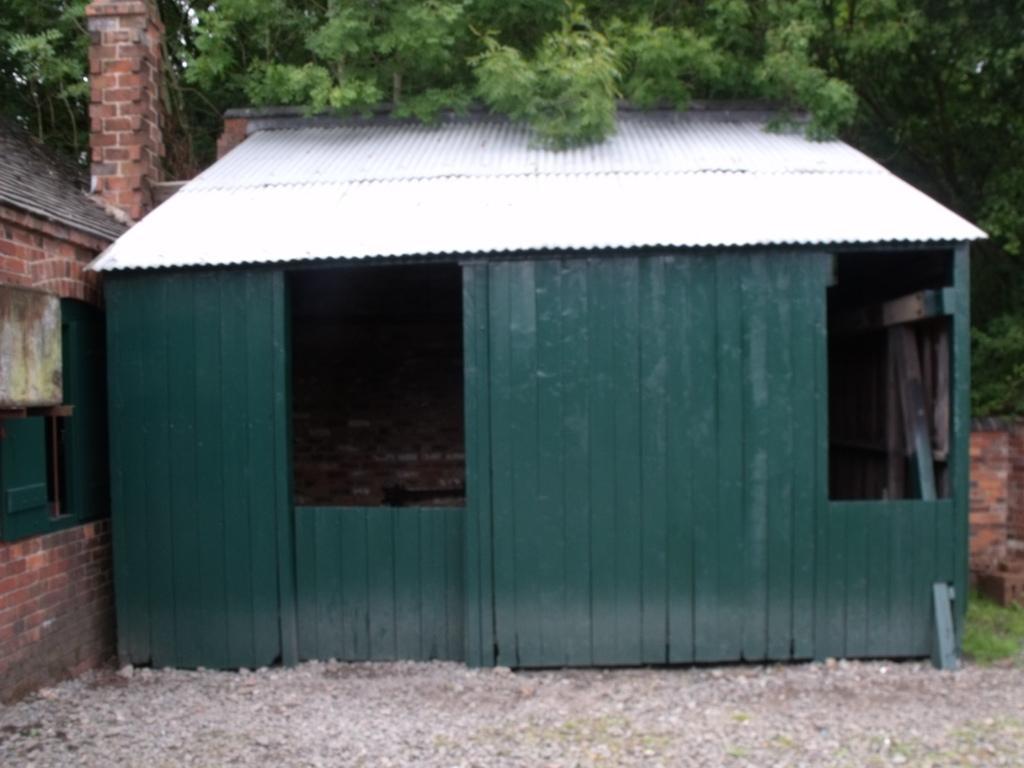What type of structure is located on the right side of the image? There is a shed with a roof in the image. What can be seen on the left side of the image? There is a house with a window in the image. Where is the house located in relation to the shed? The house is on the left side of the image. What type of vegetation is visible at the top of the image? There is a group of trees at the top of the image. What type of grape is being used to drain the roof of the shed in the image? There is no grape or drainage system visible in the image. The shed has a roof, but there is no indication of any grape or drainage system being used to remove water from the roof. 